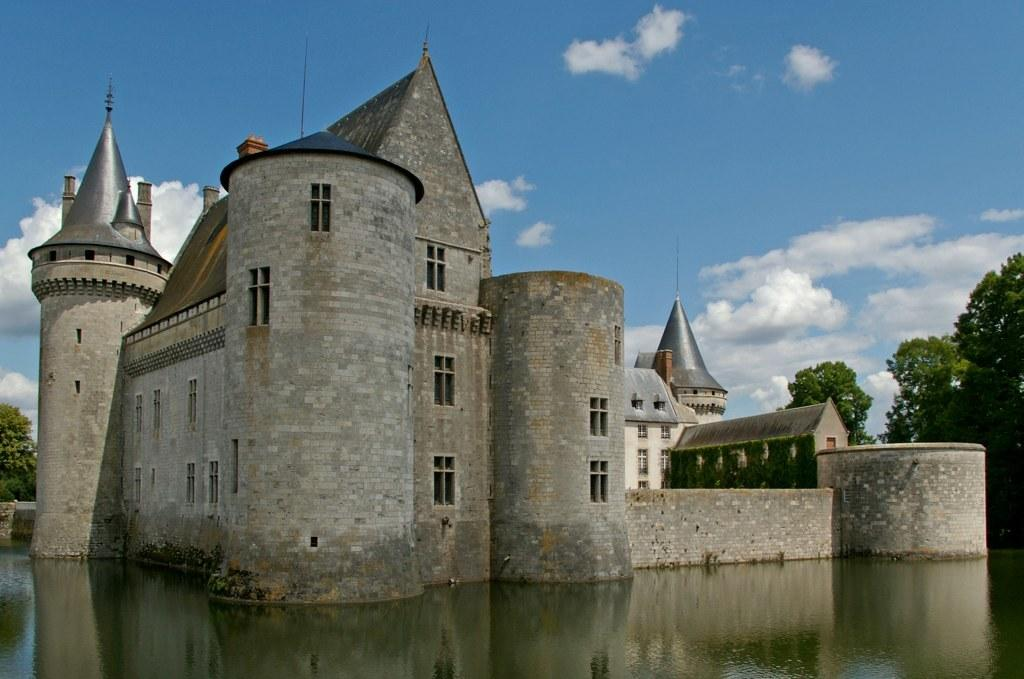What type of structure is visible in the image? There is a building in the image. What is located at the bottom of the image? There is water at the bottom of the image. Where is the tree situated in the image? There is a tree on the right side of the image. What can be seen in the sky at the top of the image? There are clouds in the sky at the top of the image. What time of day is it in the image, given the presence of bears? There are no bears present in the image, so we cannot determine the time of day based on their presence. 